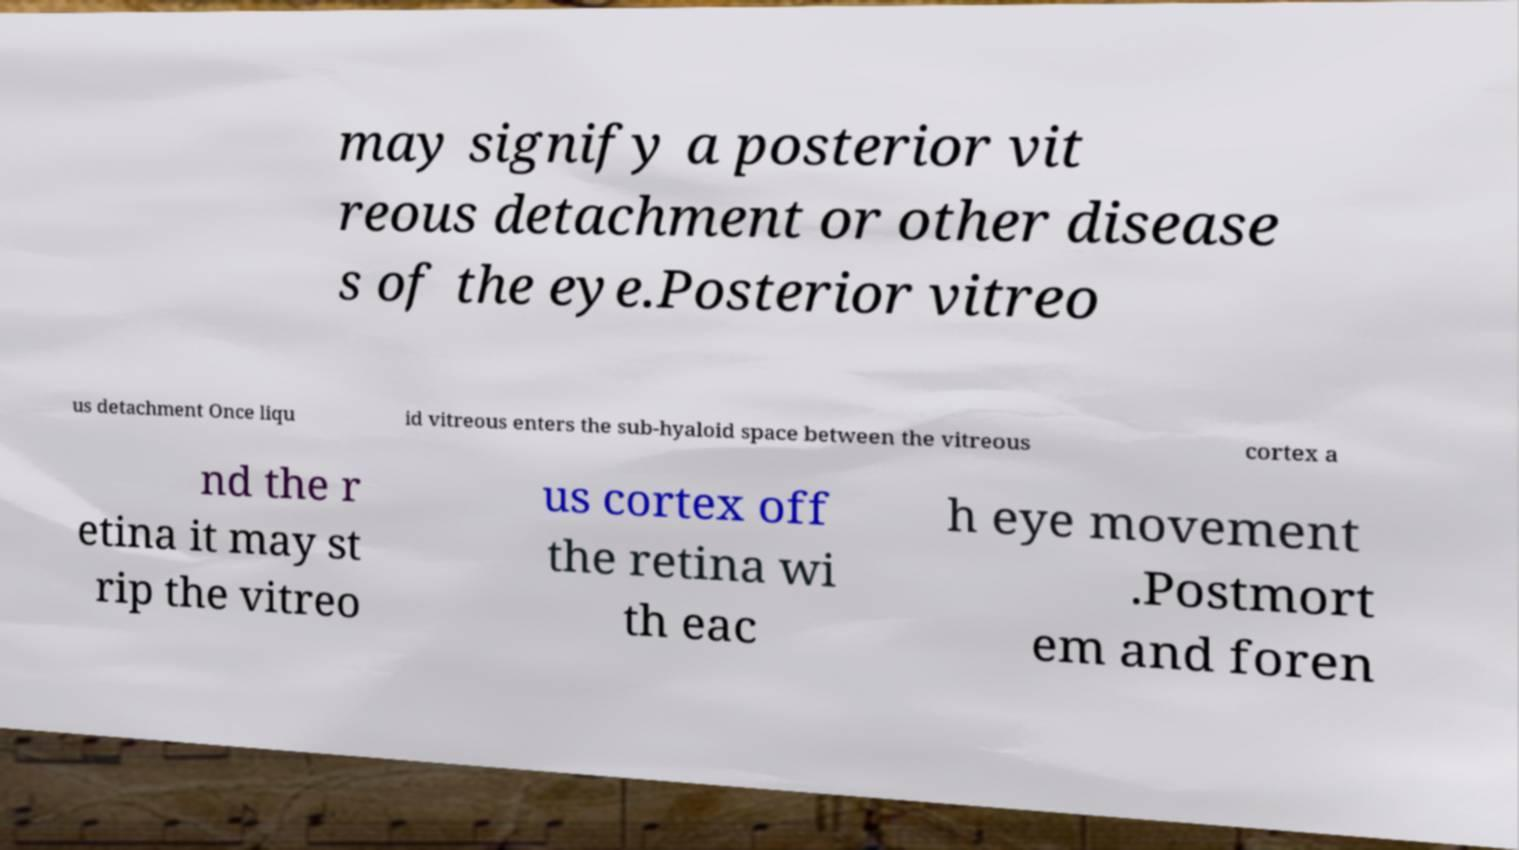For documentation purposes, I need the text within this image transcribed. Could you provide that? may signify a posterior vit reous detachment or other disease s of the eye.Posterior vitreo us detachment Once liqu id vitreous enters the sub-hyaloid space between the vitreous cortex a nd the r etina it may st rip the vitreo us cortex off the retina wi th eac h eye movement .Postmort em and foren 